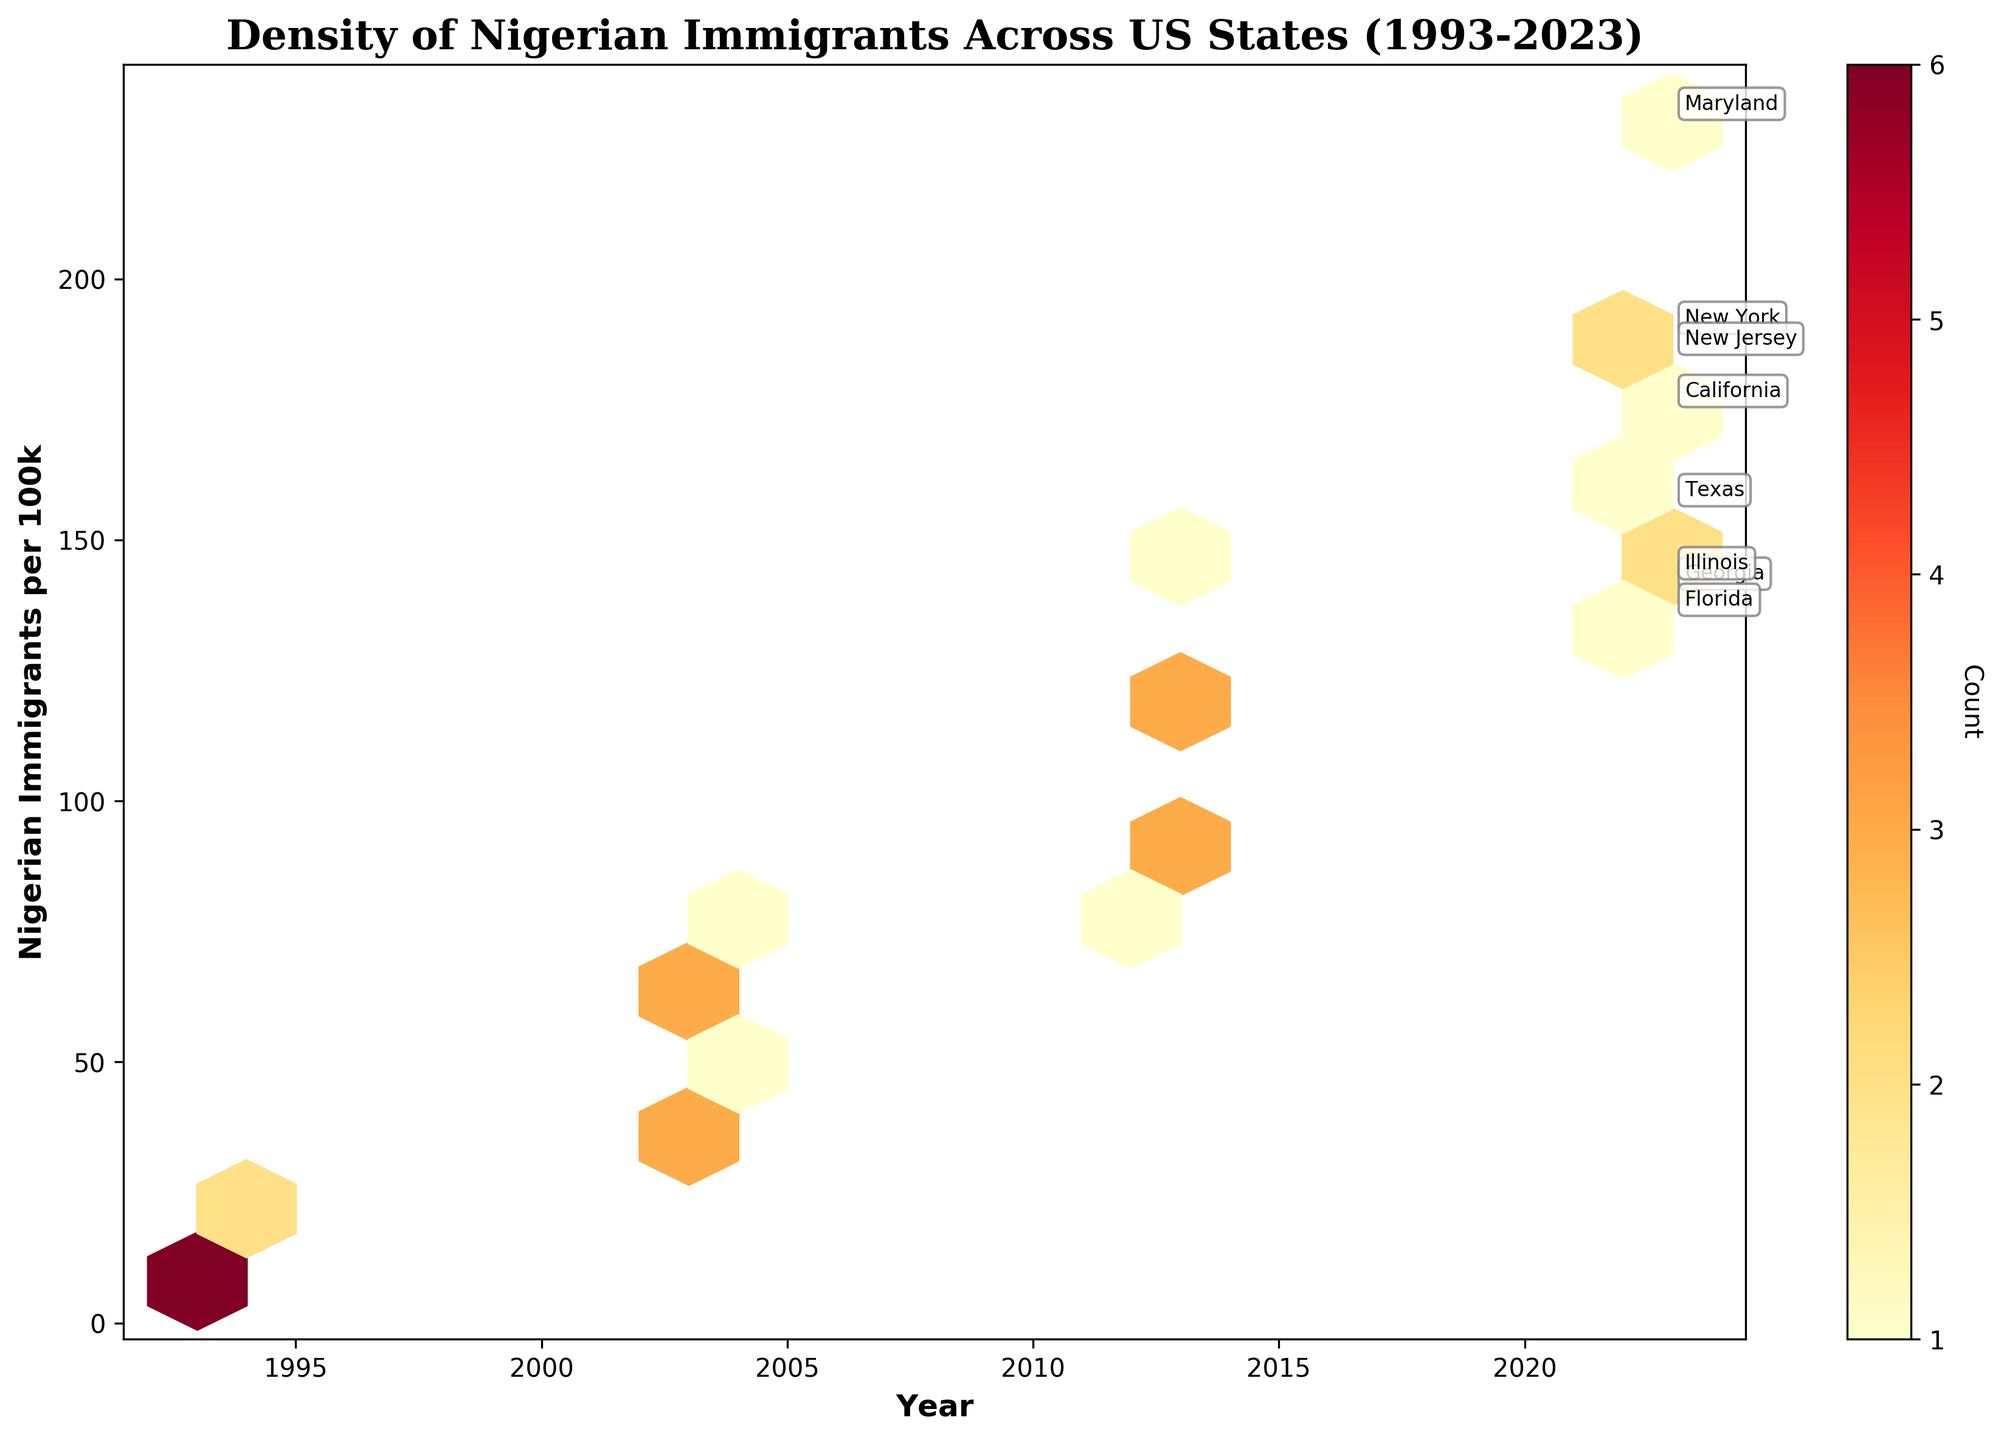What is the title of the hexbin plot? The title is located at the top center of the plot and provides a concise summary of the data being visualized. It reads "Density of Nigerian Immigrants Across US States (1993-2023)".
Answer: Density of Nigerian Immigrants Across US States (1993-2023) Which color represents the highest density of data points in the hexbin plot? The color bar on the right side of the plot helps interpret the density of data points. The warmer colors (e.g., dark red) represent higher densities, while cooler colors represent lower densities. The highest density is represented by dark red.
Answer: Dark red How many unique states are annotated in the plot? The plot contains annotations for each unique state. By counting the unique annotations, we determine there are 8 different states represented (Texas, New York, California, Maryland, Georgia, Illinois, New Jersey, Florida).
Answer: 8 In which year did Maryland see the highest density of Nigerian immigrants? By locating the "Maryland" annotation and tracing it vertically to the year axis, it is clear that in 2023, Maryland saw the highest density.
Answer: 2023 What is the approximate increase in the number of Nigerian immigrants per 100k in Texas from 1993 to 2023? The plot shows different densities for Texas at various years. By comparing the density values of Texas in 1993 and 2023, you observe the increase from around 12 per 100k in 1993 to about 156 per 100k in 2023.
Answer: 144 Which state had the highest number of Nigerian immigrants per 100k in 2023? Look for the annotated state with the highest density in 2023. Maryland is placed at the highest position on the y-axis, indicating the highest number of Nigerian immigrants per 100k in 2023.
Answer: Maryland What trend can be observed for Nigerian immigrants in California between 1993 and 2023? Follow the density changes for California across the years. The densities increase steadily from 1993 through 2023, indicating a rising trend in the number of Nigerian immigrants.
Answer: Rising trend Compare the number of Nigerian immigrants per 100k in Georgia and Illinois in 2003. Which state had more? Locate both states' densities in 2003. Georgia has around 35 per 100k, while Illinois has around 40 per 100k. Illinois had more Nigerian immigrants per 100k in 2003.
Answer: Illinois Identify which states saw the most significant increase in Nigerian immigrants per 100k from 1993 to 2023. Compare the start and end densities for all states. Maryland increased from 20 to 230 per 100k, making it the state with the most significant increase.
Answer: Maryland 